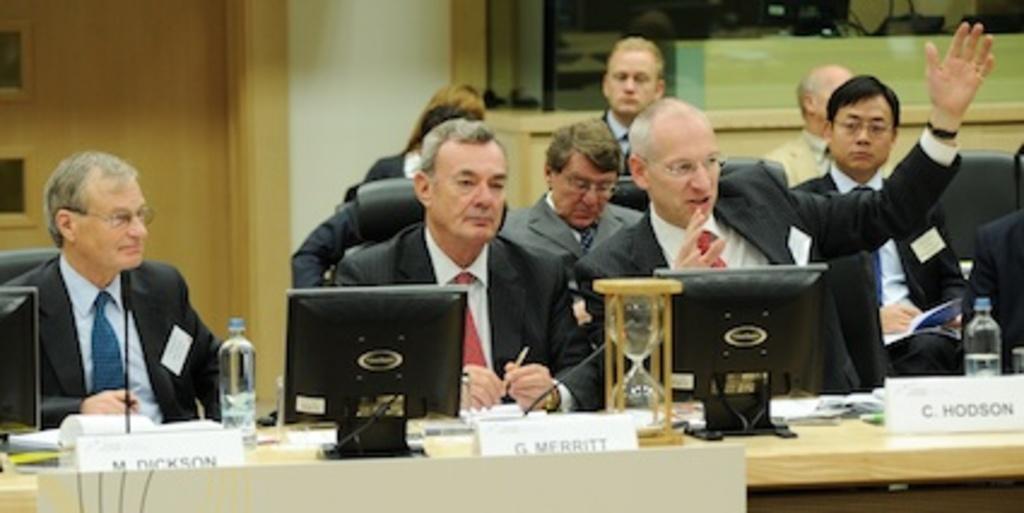Can you describe this image briefly? In this picture we can see some people are sitting on the chairs, in front we can see the table, on which we can see some systems, bottles, books, like, behind we can see few people are sitting and talking. 